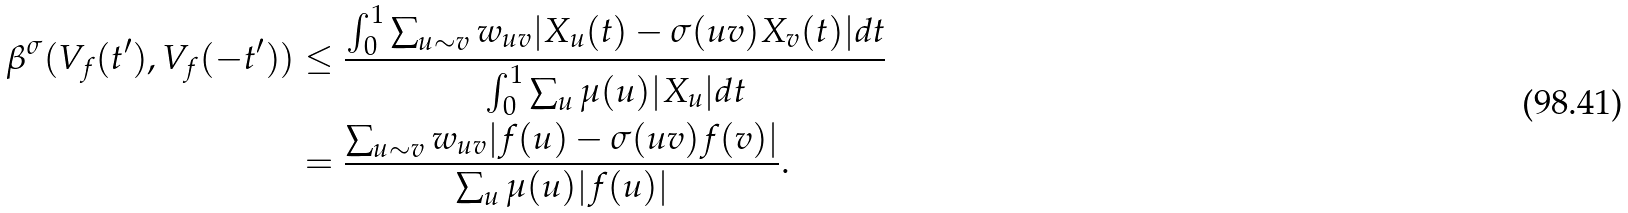<formula> <loc_0><loc_0><loc_500><loc_500>\beta ^ { \sigma } ( V _ { f } ( t ^ { \prime } ) , V _ { f } ( - t ^ { \prime } ) ) & \leq \frac { \int _ { 0 } ^ { 1 } \sum _ { u \sim v } w _ { u v } | X _ { u } ( t ) - \sigma ( u v ) X _ { v } ( t ) | d t } { \int _ { 0 } ^ { 1 } \sum _ { u } \mu ( u ) | X _ { u } | d t } \\ & = \frac { \sum _ { u \sim v } w _ { u v } | f ( u ) - \sigma ( u v ) f ( v ) | } { \sum _ { u } \mu ( u ) | f ( u ) | } .</formula> 